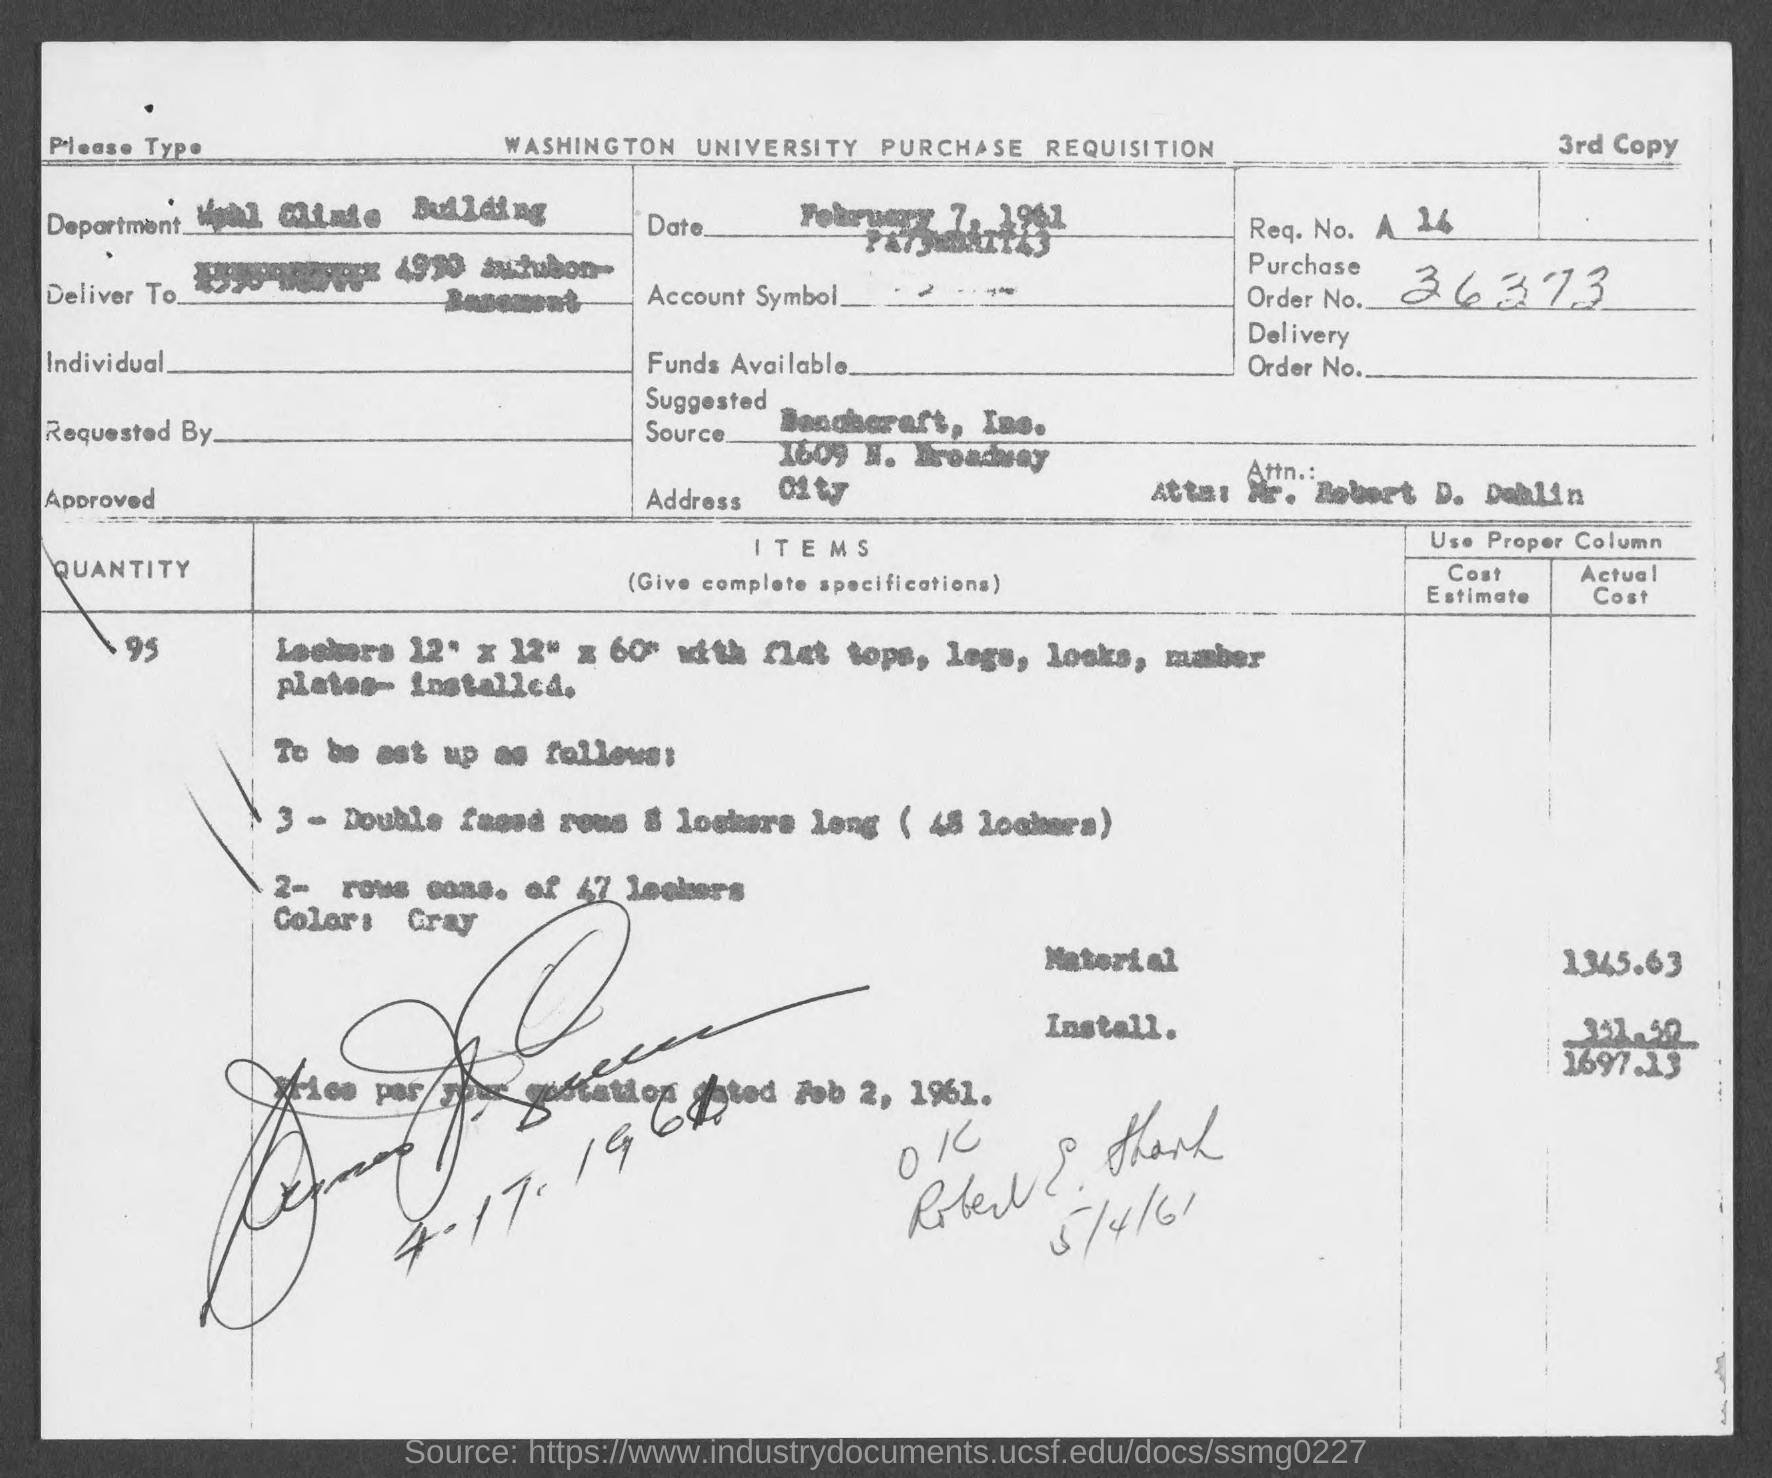What is the actual cost of material mentioned in the given page ?
Ensure brevity in your answer.  1345.63. 